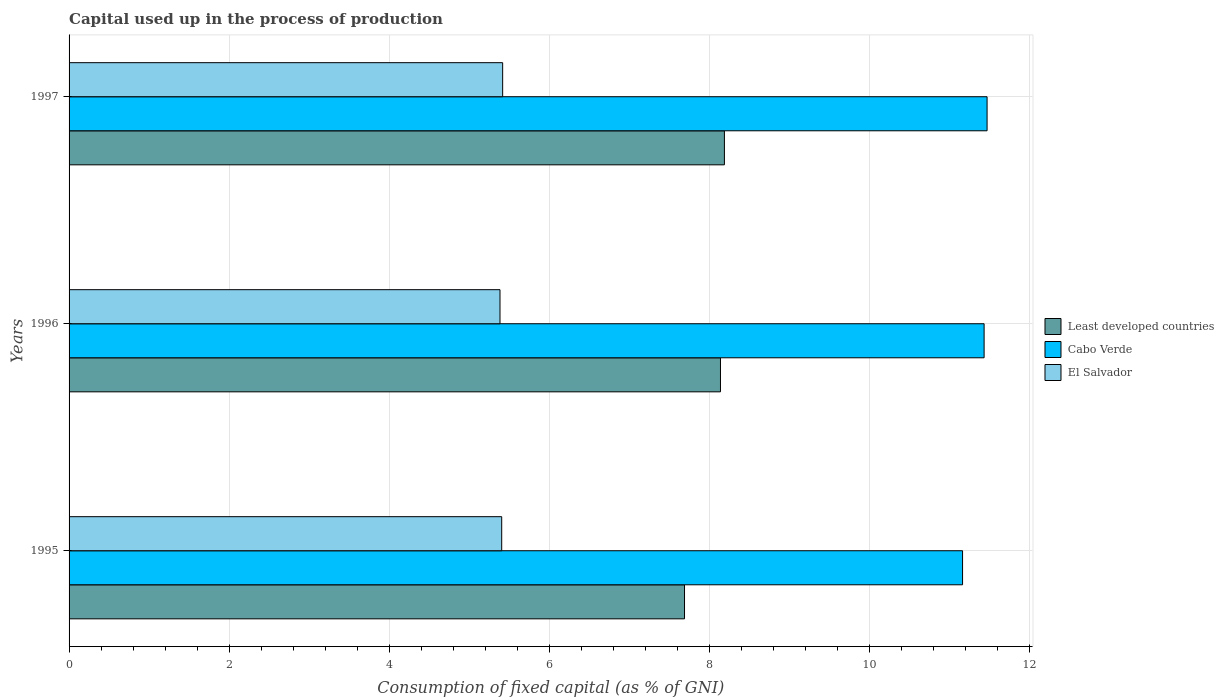How many groups of bars are there?
Your response must be concise. 3. Are the number of bars per tick equal to the number of legend labels?
Offer a very short reply. Yes. How many bars are there on the 1st tick from the bottom?
Offer a terse response. 3. What is the capital used up in the process of production in Least developed countries in 1997?
Ensure brevity in your answer.  8.19. Across all years, what is the maximum capital used up in the process of production in Cabo Verde?
Make the answer very short. 11.47. Across all years, what is the minimum capital used up in the process of production in Least developed countries?
Offer a very short reply. 7.69. In which year was the capital used up in the process of production in Cabo Verde maximum?
Your response must be concise. 1997. What is the total capital used up in the process of production in Least developed countries in the graph?
Make the answer very short. 24.01. What is the difference between the capital used up in the process of production in Least developed countries in 1995 and that in 1997?
Your answer should be very brief. -0.5. What is the difference between the capital used up in the process of production in Cabo Verde in 1996 and the capital used up in the process of production in El Salvador in 1995?
Give a very brief answer. 6.03. What is the average capital used up in the process of production in Least developed countries per year?
Your response must be concise. 8. In the year 1996, what is the difference between the capital used up in the process of production in El Salvador and capital used up in the process of production in Cabo Verde?
Your answer should be compact. -6.05. In how many years, is the capital used up in the process of production in Least developed countries greater than 8.4 %?
Your answer should be compact. 0. What is the ratio of the capital used up in the process of production in El Salvador in 1996 to that in 1997?
Keep it short and to the point. 0.99. Is the capital used up in the process of production in El Salvador in 1995 less than that in 1997?
Ensure brevity in your answer.  Yes. Is the difference between the capital used up in the process of production in El Salvador in 1995 and 1996 greater than the difference between the capital used up in the process of production in Cabo Verde in 1995 and 1996?
Your answer should be compact. Yes. What is the difference between the highest and the second highest capital used up in the process of production in Cabo Verde?
Give a very brief answer. 0.04. What is the difference between the highest and the lowest capital used up in the process of production in El Salvador?
Keep it short and to the point. 0.03. What does the 1st bar from the top in 1995 represents?
Give a very brief answer. El Salvador. What does the 3rd bar from the bottom in 1997 represents?
Ensure brevity in your answer.  El Salvador. Is it the case that in every year, the sum of the capital used up in the process of production in El Salvador and capital used up in the process of production in Cabo Verde is greater than the capital used up in the process of production in Least developed countries?
Your answer should be compact. Yes. How many bars are there?
Keep it short and to the point. 9. How many years are there in the graph?
Offer a very short reply. 3. What is the difference between two consecutive major ticks on the X-axis?
Your answer should be very brief. 2. Does the graph contain any zero values?
Your answer should be very brief. No. Does the graph contain grids?
Offer a very short reply. Yes. Where does the legend appear in the graph?
Offer a terse response. Center right. How are the legend labels stacked?
Offer a terse response. Vertical. What is the title of the graph?
Make the answer very short. Capital used up in the process of production. Does "Bosnia and Herzegovina" appear as one of the legend labels in the graph?
Your response must be concise. No. What is the label or title of the X-axis?
Your answer should be compact. Consumption of fixed capital (as % of GNI). What is the Consumption of fixed capital (as % of GNI) in Least developed countries in 1995?
Your answer should be very brief. 7.69. What is the Consumption of fixed capital (as % of GNI) of Cabo Verde in 1995?
Make the answer very short. 11.16. What is the Consumption of fixed capital (as % of GNI) in El Salvador in 1995?
Give a very brief answer. 5.4. What is the Consumption of fixed capital (as % of GNI) in Least developed countries in 1996?
Provide a succinct answer. 8.14. What is the Consumption of fixed capital (as % of GNI) of Cabo Verde in 1996?
Ensure brevity in your answer.  11.43. What is the Consumption of fixed capital (as % of GNI) in El Salvador in 1996?
Make the answer very short. 5.38. What is the Consumption of fixed capital (as % of GNI) of Least developed countries in 1997?
Provide a short and direct response. 8.19. What is the Consumption of fixed capital (as % of GNI) of Cabo Verde in 1997?
Provide a short and direct response. 11.47. What is the Consumption of fixed capital (as % of GNI) in El Salvador in 1997?
Provide a short and direct response. 5.42. Across all years, what is the maximum Consumption of fixed capital (as % of GNI) of Least developed countries?
Your answer should be very brief. 8.19. Across all years, what is the maximum Consumption of fixed capital (as % of GNI) of Cabo Verde?
Make the answer very short. 11.47. Across all years, what is the maximum Consumption of fixed capital (as % of GNI) in El Salvador?
Provide a short and direct response. 5.42. Across all years, what is the minimum Consumption of fixed capital (as % of GNI) in Least developed countries?
Offer a terse response. 7.69. Across all years, what is the minimum Consumption of fixed capital (as % of GNI) in Cabo Verde?
Your answer should be very brief. 11.16. Across all years, what is the minimum Consumption of fixed capital (as % of GNI) in El Salvador?
Make the answer very short. 5.38. What is the total Consumption of fixed capital (as % of GNI) of Least developed countries in the graph?
Provide a succinct answer. 24.01. What is the total Consumption of fixed capital (as % of GNI) in Cabo Verde in the graph?
Offer a terse response. 34.06. What is the total Consumption of fixed capital (as % of GNI) of El Salvador in the graph?
Give a very brief answer. 16.2. What is the difference between the Consumption of fixed capital (as % of GNI) of Least developed countries in 1995 and that in 1996?
Offer a terse response. -0.45. What is the difference between the Consumption of fixed capital (as % of GNI) of Cabo Verde in 1995 and that in 1996?
Ensure brevity in your answer.  -0.27. What is the difference between the Consumption of fixed capital (as % of GNI) in El Salvador in 1995 and that in 1996?
Offer a very short reply. 0.02. What is the difference between the Consumption of fixed capital (as % of GNI) in Least developed countries in 1995 and that in 1997?
Keep it short and to the point. -0.5. What is the difference between the Consumption of fixed capital (as % of GNI) of Cabo Verde in 1995 and that in 1997?
Offer a very short reply. -0.31. What is the difference between the Consumption of fixed capital (as % of GNI) in El Salvador in 1995 and that in 1997?
Your answer should be compact. -0.01. What is the difference between the Consumption of fixed capital (as % of GNI) in Least developed countries in 1996 and that in 1997?
Give a very brief answer. -0.05. What is the difference between the Consumption of fixed capital (as % of GNI) of Cabo Verde in 1996 and that in 1997?
Your response must be concise. -0.04. What is the difference between the Consumption of fixed capital (as % of GNI) of El Salvador in 1996 and that in 1997?
Your response must be concise. -0.03. What is the difference between the Consumption of fixed capital (as % of GNI) of Least developed countries in 1995 and the Consumption of fixed capital (as % of GNI) of Cabo Verde in 1996?
Your answer should be very brief. -3.74. What is the difference between the Consumption of fixed capital (as % of GNI) of Least developed countries in 1995 and the Consumption of fixed capital (as % of GNI) of El Salvador in 1996?
Your answer should be compact. 2.31. What is the difference between the Consumption of fixed capital (as % of GNI) in Cabo Verde in 1995 and the Consumption of fixed capital (as % of GNI) in El Salvador in 1996?
Offer a very short reply. 5.78. What is the difference between the Consumption of fixed capital (as % of GNI) of Least developed countries in 1995 and the Consumption of fixed capital (as % of GNI) of Cabo Verde in 1997?
Ensure brevity in your answer.  -3.78. What is the difference between the Consumption of fixed capital (as % of GNI) in Least developed countries in 1995 and the Consumption of fixed capital (as % of GNI) in El Salvador in 1997?
Your answer should be compact. 2.27. What is the difference between the Consumption of fixed capital (as % of GNI) in Cabo Verde in 1995 and the Consumption of fixed capital (as % of GNI) in El Salvador in 1997?
Offer a terse response. 5.75. What is the difference between the Consumption of fixed capital (as % of GNI) in Least developed countries in 1996 and the Consumption of fixed capital (as % of GNI) in Cabo Verde in 1997?
Ensure brevity in your answer.  -3.33. What is the difference between the Consumption of fixed capital (as % of GNI) in Least developed countries in 1996 and the Consumption of fixed capital (as % of GNI) in El Salvador in 1997?
Offer a very short reply. 2.72. What is the difference between the Consumption of fixed capital (as % of GNI) of Cabo Verde in 1996 and the Consumption of fixed capital (as % of GNI) of El Salvador in 1997?
Your answer should be very brief. 6.01. What is the average Consumption of fixed capital (as % of GNI) of Least developed countries per year?
Make the answer very short. 8. What is the average Consumption of fixed capital (as % of GNI) in Cabo Verde per year?
Keep it short and to the point. 11.35. What is the average Consumption of fixed capital (as % of GNI) in El Salvador per year?
Offer a terse response. 5.4. In the year 1995, what is the difference between the Consumption of fixed capital (as % of GNI) of Least developed countries and Consumption of fixed capital (as % of GNI) of Cabo Verde?
Offer a terse response. -3.47. In the year 1995, what is the difference between the Consumption of fixed capital (as % of GNI) in Least developed countries and Consumption of fixed capital (as % of GNI) in El Salvador?
Give a very brief answer. 2.28. In the year 1995, what is the difference between the Consumption of fixed capital (as % of GNI) of Cabo Verde and Consumption of fixed capital (as % of GNI) of El Salvador?
Your answer should be very brief. 5.76. In the year 1996, what is the difference between the Consumption of fixed capital (as % of GNI) in Least developed countries and Consumption of fixed capital (as % of GNI) in Cabo Verde?
Your answer should be compact. -3.29. In the year 1996, what is the difference between the Consumption of fixed capital (as % of GNI) of Least developed countries and Consumption of fixed capital (as % of GNI) of El Salvador?
Provide a short and direct response. 2.75. In the year 1996, what is the difference between the Consumption of fixed capital (as % of GNI) of Cabo Verde and Consumption of fixed capital (as % of GNI) of El Salvador?
Give a very brief answer. 6.05. In the year 1997, what is the difference between the Consumption of fixed capital (as % of GNI) of Least developed countries and Consumption of fixed capital (as % of GNI) of Cabo Verde?
Provide a short and direct response. -3.28. In the year 1997, what is the difference between the Consumption of fixed capital (as % of GNI) in Least developed countries and Consumption of fixed capital (as % of GNI) in El Salvador?
Your answer should be compact. 2.77. In the year 1997, what is the difference between the Consumption of fixed capital (as % of GNI) of Cabo Verde and Consumption of fixed capital (as % of GNI) of El Salvador?
Offer a very short reply. 6.05. What is the ratio of the Consumption of fixed capital (as % of GNI) in Least developed countries in 1995 to that in 1996?
Your answer should be compact. 0.94. What is the ratio of the Consumption of fixed capital (as % of GNI) in Cabo Verde in 1995 to that in 1996?
Keep it short and to the point. 0.98. What is the ratio of the Consumption of fixed capital (as % of GNI) of El Salvador in 1995 to that in 1996?
Your answer should be very brief. 1. What is the ratio of the Consumption of fixed capital (as % of GNI) in Least developed countries in 1995 to that in 1997?
Offer a terse response. 0.94. What is the ratio of the Consumption of fixed capital (as % of GNI) in Cabo Verde in 1995 to that in 1997?
Offer a terse response. 0.97. What is the ratio of the Consumption of fixed capital (as % of GNI) in Least developed countries in 1996 to that in 1997?
Your answer should be very brief. 0.99. What is the difference between the highest and the second highest Consumption of fixed capital (as % of GNI) of Least developed countries?
Ensure brevity in your answer.  0.05. What is the difference between the highest and the second highest Consumption of fixed capital (as % of GNI) in Cabo Verde?
Keep it short and to the point. 0.04. What is the difference between the highest and the second highest Consumption of fixed capital (as % of GNI) of El Salvador?
Offer a terse response. 0.01. What is the difference between the highest and the lowest Consumption of fixed capital (as % of GNI) of Least developed countries?
Ensure brevity in your answer.  0.5. What is the difference between the highest and the lowest Consumption of fixed capital (as % of GNI) of Cabo Verde?
Provide a short and direct response. 0.31. What is the difference between the highest and the lowest Consumption of fixed capital (as % of GNI) in El Salvador?
Provide a succinct answer. 0.03. 